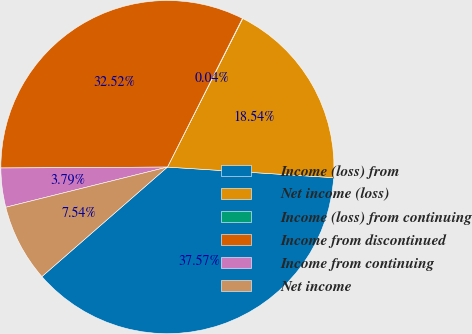Convert chart to OTSL. <chart><loc_0><loc_0><loc_500><loc_500><pie_chart><fcel>Income (loss) from<fcel>Net income (loss)<fcel>Income (loss) from continuing<fcel>Income from discontinued<fcel>Income from continuing<fcel>Net income<nl><fcel>37.57%<fcel>18.54%<fcel>0.04%<fcel>32.52%<fcel>3.79%<fcel>7.54%<nl></chart> 